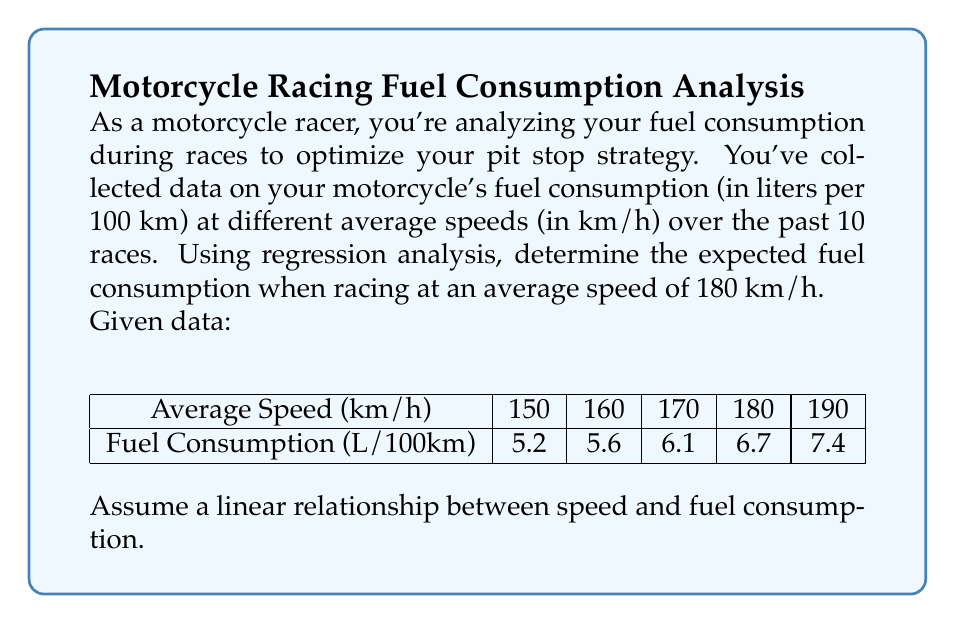Give your solution to this math problem. To solve this problem, we'll use simple linear regression. Let's follow these steps:

1) First, we need to calculate the means of x (speed) and y (fuel consumption):

   $\bar{x} = \frac{150 + 160 + 170 + 180 + 190}{5} = 170$
   $\bar{y} = \frac{5.2 + 5.6 + 6.1 + 6.7 + 7.4}{5} = 6.2$

2) Now, we'll calculate the slope (b) of the regression line:

   $$b = \frac{\sum(x_i - \bar{x})(y_i - \bar{y})}{\sum(x_i - \bar{x})^2}$$

   Let's calculate the numerator and denominator separately:

   Numerator: $(-20)(-1) + (-10)(-0.6) + (0)(-0.1) + (10)(0.5) + (20)(1.2) = 44$
   Denominator: $(-20)^2 + (-10)^2 + (0)^2 + (10)^2 + (20)^2 = 1000$

   $$b = \frac{44}{1000} = 0.044$$

3) Next, we'll calculate the y-intercept (a):

   $$a = \bar{y} - b\bar{x} = 6.2 - (0.044)(170) = -1.28$$

4) Our regression equation is:

   $$y = 0.044x - 1.28$$

5) To find the expected fuel consumption at 180 km/h, we substitute x = 180:

   $$y = 0.044(180) - 1.28 = 6.64$$

Therefore, the expected fuel consumption at 180 km/h is 6.64 L/100km.
Answer: 6.64 L/100km 